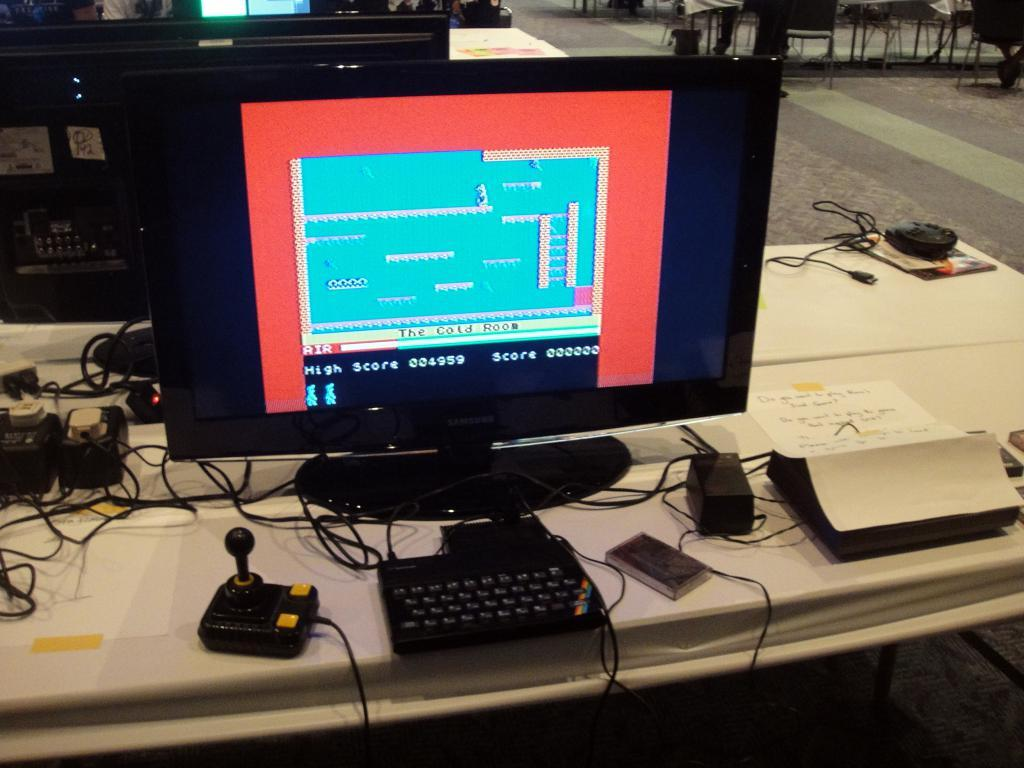Provide a one-sentence caption for the provided image. The game shows that they are currently in The Cold Room. 